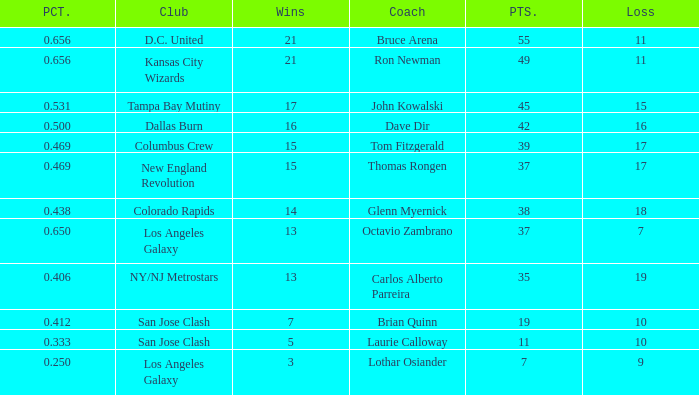What is the sum of points when Bruce Arena has 21 wins? 55.0. Would you mind parsing the complete table? {'header': ['PCT.', 'Club', 'Wins', 'Coach', 'PTS.', 'Loss'], 'rows': [['0.656', 'D.C. United', '21', 'Bruce Arena', '55', '11'], ['0.656', 'Kansas City Wizards', '21', 'Ron Newman', '49', '11'], ['0.531', 'Tampa Bay Mutiny', '17', 'John Kowalski', '45', '15'], ['0.500', 'Dallas Burn', '16', 'Dave Dir', '42', '16'], ['0.469', 'Columbus Crew', '15', 'Tom Fitzgerald', '39', '17'], ['0.469', 'New England Revolution', '15', 'Thomas Rongen', '37', '17'], ['0.438', 'Colorado Rapids', '14', 'Glenn Myernick', '38', '18'], ['0.650', 'Los Angeles Galaxy', '13', 'Octavio Zambrano', '37', '7'], ['0.406', 'NY/NJ Metrostars', '13', 'Carlos Alberto Parreira', '35', '19'], ['0.412', 'San Jose Clash', '7', 'Brian Quinn', '19', '10'], ['0.333', 'San Jose Clash', '5', 'Laurie Calloway', '11', '10'], ['0.250', 'Los Angeles Galaxy', '3', 'Lothar Osiander', '7', '9']]} 